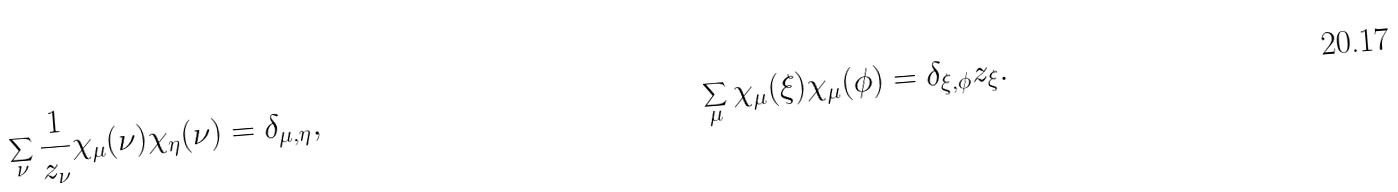Convert formula to latex. <formula><loc_0><loc_0><loc_500><loc_500>\sum _ { \nu } \frac { 1 } { z _ { \nu } } \chi _ { \mu } ( \nu ) \chi _ { \eta } ( \nu ) & = \delta _ { \mu , \eta } , & \sum _ { \mu } \chi _ { \mu } ( \xi ) \chi _ { \mu } ( \phi ) = \delta _ { \xi , \phi } z _ { \xi } .</formula> 